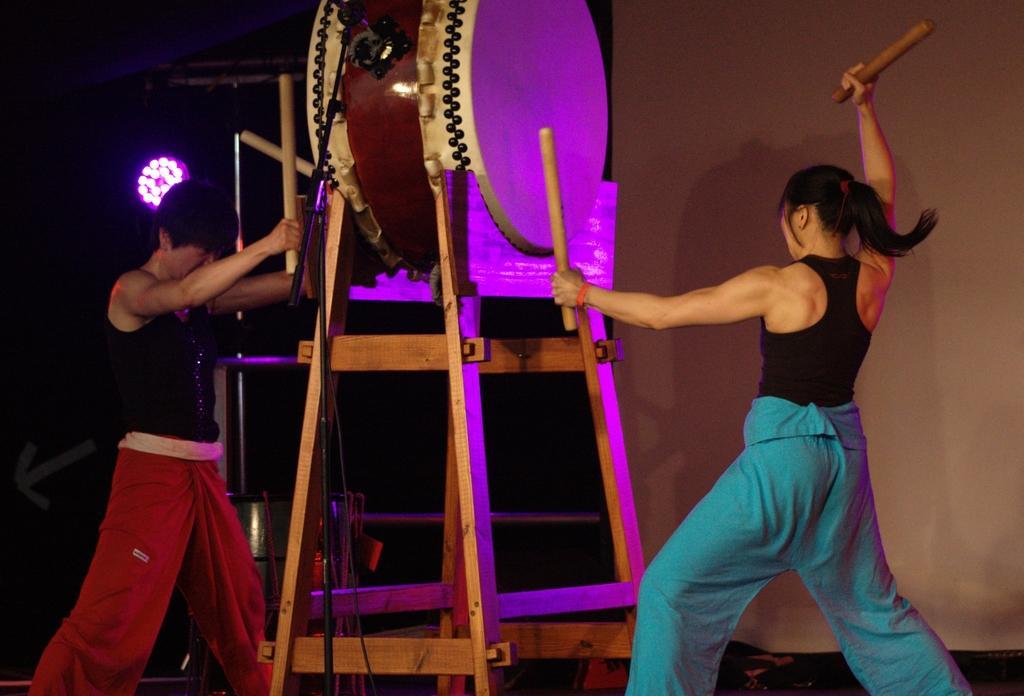Please provide a concise description of this image. 2 people are playing a huge drum. they are wearing black waist. the person at the left is wearing red pant. the person at the right is wearing green pant. behind them there is a pink light. the drum is placed on a wooden stool. 